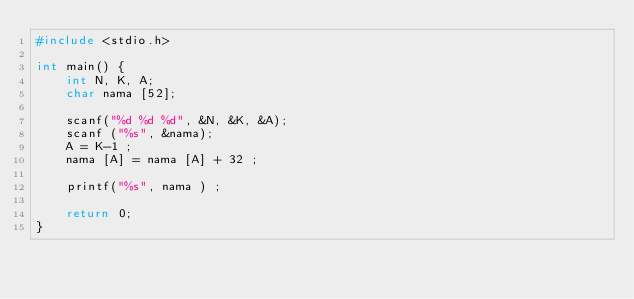<code> <loc_0><loc_0><loc_500><loc_500><_C++_>#include <stdio.h>
 
int main() {
	int N, K, A;
	char nama [52];

	scanf("%d %d %d", &N, &K, &A);
	scanf ("%s", &nama);
	A = K-1 ;
	nama [A] = nama [A] + 32 ;

	printf("%s", nama ) ;
	
	return 0;
}</code> 